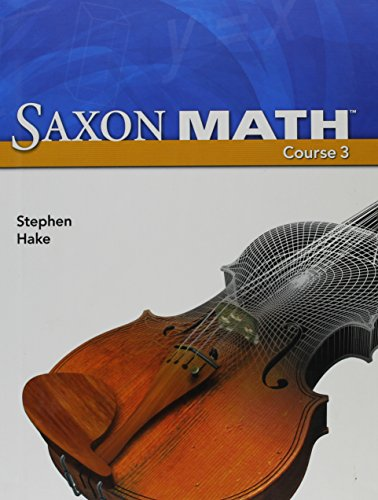Is this book related to Law? No, this book is solely focused on mathematics education and does not cover any topics related to Law. 